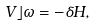<formula> <loc_0><loc_0><loc_500><loc_500>V \rfloor \omega = - \delta H ,</formula> 